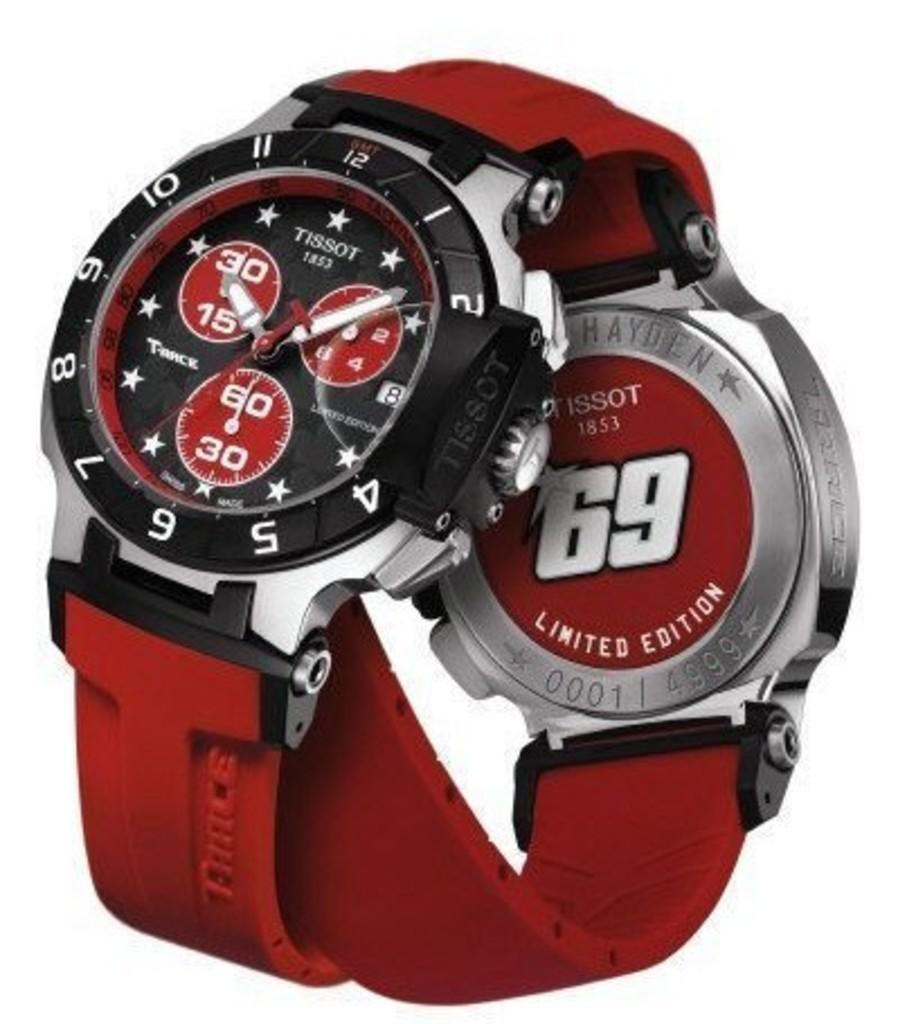<image>
Offer a succinct explanation of the picture presented. A red and black Tissot watch has three red circles on the face. 